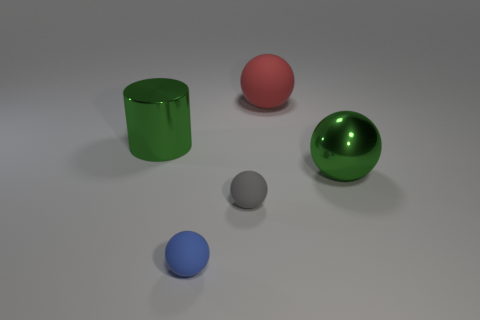Are there any shiny objects that are on the left side of the rubber object on the left side of the gray ball?
Offer a very short reply. Yes. There is a big shiny object in front of the large green metallic cylinder; does it have the same shape as the red object?
Offer a very short reply. Yes. Is there anything else that is the same shape as the small blue object?
Offer a very short reply. Yes. What number of cylinders are either large red rubber objects or blue objects?
Keep it short and to the point. 0. What number of spheres are there?
Your response must be concise. 4. There is a blue ball that is in front of the rubber thing that is on the right side of the gray rubber sphere; what size is it?
Your answer should be very brief. Small. How many other objects are there of the same size as the blue thing?
Provide a succinct answer. 1. What number of large green objects are left of the blue rubber ball?
Offer a very short reply. 1. What size is the blue ball?
Offer a very short reply. Small. Are the red ball that is right of the large cylinder and the small gray thing that is in front of the large shiny sphere made of the same material?
Make the answer very short. Yes. 